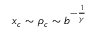<formula> <loc_0><loc_0><loc_500><loc_500>x _ { c } \sim \rho _ { c } \sim b ^ { - \frac { 1 } { \gamma } }</formula> 